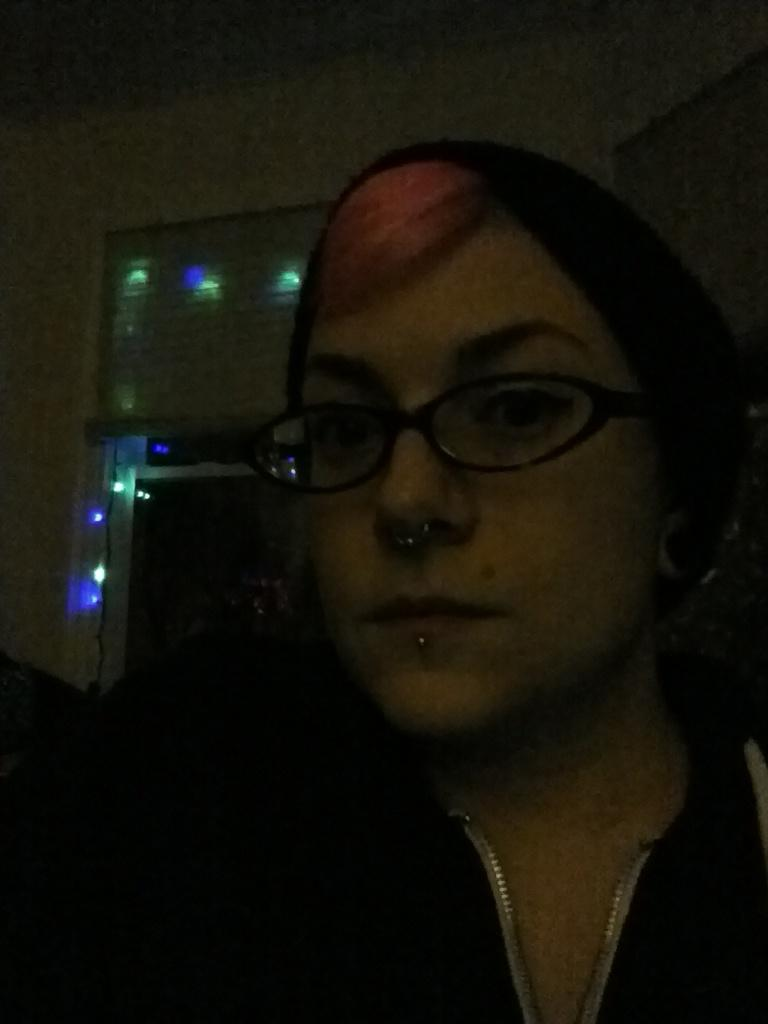Who or what is the main subject in the image? There is a person in the center of the image. Can you describe the person's appearance? The person is wearing glasses. What can be seen in the background of the image? There are lights and a wall in the background of the image. What type of apparatus is being used to spread hate in the image? There is no apparatus or any indication of hate present in the image. 